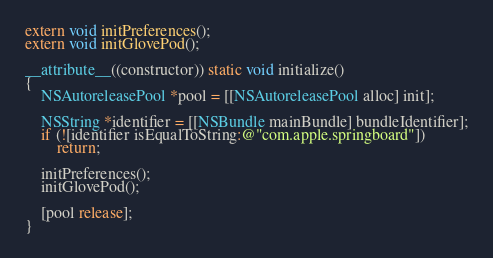<code> <loc_0><loc_0><loc_500><loc_500><_ObjectiveC_>extern void initPreferences();
extern void initGlovePod();

__attribute__((constructor)) static void initialize()
{
    NSAutoreleasePool *pool = [[NSAutoreleasePool alloc] init];

    NSString *identifier = [[NSBundle mainBundle] bundleIdentifier];
    if (![identifier isEqualToString:@"com.apple.springboard"])
        return;

    initPreferences();
    initGlovePod();

    [pool release];
}
</code> 